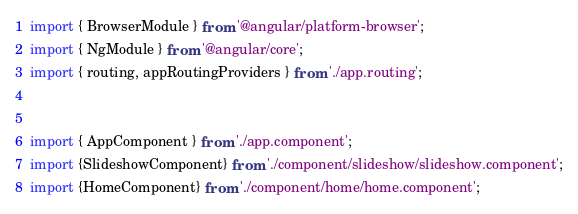<code> <loc_0><loc_0><loc_500><loc_500><_TypeScript_>import { BrowserModule } from '@angular/platform-browser';
import { NgModule } from '@angular/core';
import { routing, appRoutingProviders } from './app.routing';


import { AppComponent } from './app.component';
import {SlideshowComponent} from './component/slideshow/slideshow.component';
import {HomeComponent} from './component/home/home.component';</code> 